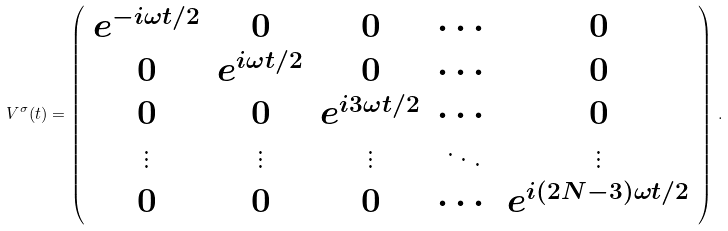<formula> <loc_0><loc_0><loc_500><loc_500>V ^ { \sigma } ( t ) = \left ( \begin{array} { c c c c c } e ^ { - i \omega t / 2 } & 0 & 0 & \cdots & 0 \\ 0 & e ^ { i \omega t / 2 } & 0 & \cdots & 0 \\ 0 & 0 & e ^ { i 3 \omega t / 2 } & \cdots & 0 \\ \vdots & \vdots & \vdots & \ddots & \vdots \\ 0 & 0 & 0 & \cdots & e ^ { i ( 2 N - 3 ) \omega t / 2 } \end{array} \right ) \, .</formula> 